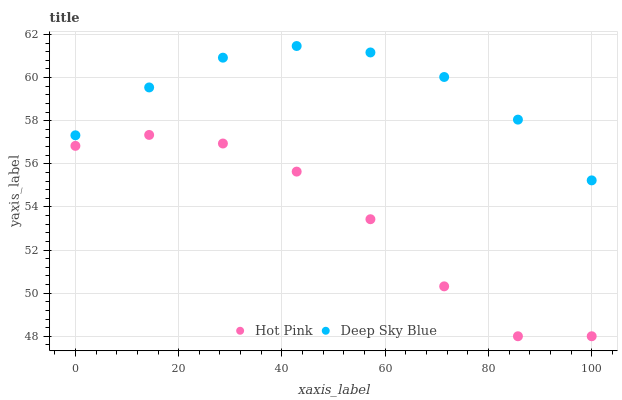Does Hot Pink have the minimum area under the curve?
Answer yes or no. Yes. Does Deep Sky Blue have the maximum area under the curve?
Answer yes or no. Yes. Does Deep Sky Blue have the minimum area under the curve?
Answer yes or no. No. Is Deep Sky Blue the smoothest?
Answer yes or no. Yes. Is Hot Pink the roughest?
Answer yes or no. Yes. Is Deep Sky Blue the roughest?
Answer yes or no. No. Does Hot Pink have the lowest value?
Answer yes or no. Yes. Does Deep Sky Blue have the lowest value?
Answer yes or no. No. Does Deep Sky Blue have the highest value?
Answer yes or no. Yes. Is Hot Pink less than Deep Sky Blue?
Answer yes or no. Yes. Is Deep Sky Blue greater than Hot Pink?
Answer yes or no. Yes. Does Hot Pink intersect Deep Sky Blue?
Answer yes or no. No. 